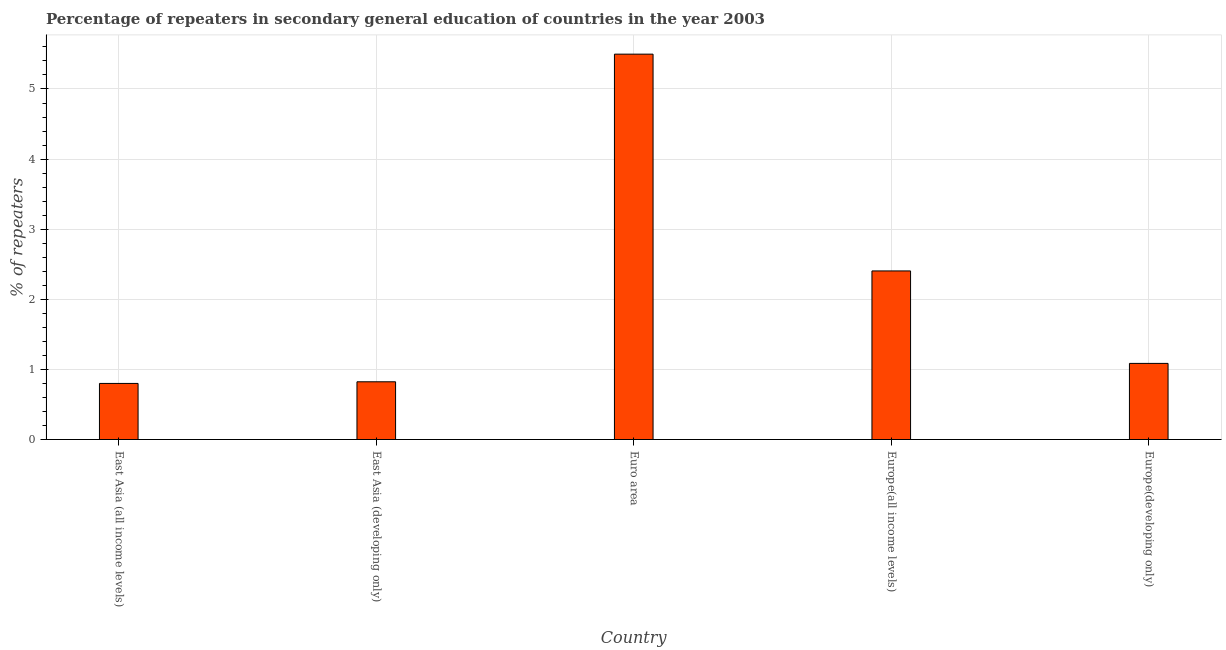Does the graph contain any zero values?
Give a very brief answer. No. What is the title of the graph?
Provide a succinct answer. Percentage of repeaters in secondary general education of countries in the year 2003. What is the label or title of the Y-axis?
Offer a terse response. % of repeaters. What is the percentage of repeaters in East Asia (developing only)?
Keep it short and to the point. 0.82. Across all countries, what is the maximum percentage of repeaters?
Offer a very short reply. 5.5. Across all countries, what is the minimum percentage of repeaters?
Provide a succinct answer. 0.8. In which country was the percentage of repeaters minimum?
Ensure brevity in your answer.  East Asia (all income levels). What is the sum of the percentage of repeaters?
Your answer should be compact. 10.61. What is the difference between the percentage of repeaters in East Asia (developing only) and Euro area?
Your answer should be compact. -4.67. What is the average percentage of repeaters per country?
Offer a terse response. 2.12. What is the median percentage of repeaters?
Offer a terse response. 1.09. In how many countries, is the percentage of repeaters greater than 2 %?
Offer a very short reply. 2. Is the difference between the percentage of repeaters in East Asia (developing only) and Euro area greater than the difference between any two countries?
Ensure brevity in your answer.  No. What is the difference between the highest and the second highest percentage of repeaters?
Make the answer very short. 3.09. What is the difference between the highest and the lowest percentage of repeaters?
Your response must be concise. 4.7. How many countries are there in the graph?
Provide a succinct answer. 5. What is the difference between two consecutive major ticks on the Y-axis?
Your answer should be compact. 1. What is the % of repeaters in East Asia (all income levels)?
Your response must be concise. 0.8. What is the % of repeaters in East Asia (developing only)?
Ensure brevity in your answer.  0.82. What is the % of repeaters of Euro area?
Give a very brief answer. 5.5. What is the % of repeaters in Europe(all income levels)?
Make the answer very short. 2.4. What is the % of repeaters of Europe(developing only)?
Offer a very short reply. 1.09. What is the difference between the % of repeaters in East Asia (all income levels) and East Asia (developing only)?
Keep it short and to the point. -0.02. What is the difference between the % of repeaters in East Asia (all income levels) and Euro area?
Give a very brief answer. -4.7. What is the difference between the % of repeaters in East Asia (all income levels) and Europe(all income levels)?
Your answer should be very brief. -1.6. What is the difference between the % of repeaters in East Asia (all income levels) and Europe(developing only)?
Offer a terse response. -0.29. What is the difference between the % of repeaters in East Asia (developing only) and Euro area?
Make the answer very short. -4.67. What is the difference between the % of repeaters in East Asia (developing only) and Europe(all income levels)?
Make the answer very short. -1.58. What is the difference between the % of repeaters in East Asia (developing only) and Europe(developing only)?
Give a very brief answer. -0.26. What is the difference between the % of repeaters in Euro area and Europe(all income levels)?
Provide a short and direct response. 3.09. What is the difference between the % of repeaters in Euro area and Europe(developing only)?
Give a very brief answer. 4.41. What is the difference between the % of repeaters in Europe(all income levels) and Europe(developing only)?
Offer a terse response. 1.32. What is the ratio of the % of repeaters in East Asia (all income levels) to that in Euro area?
Your response must be concise. 0.15. What is the ratio of the % of repeaters in East Asia (all income levels) to that in Europe(all income levels)?
Keep it short and to the point. 0.33. What is the ratio of the % of repeaters in East Asia (all income levels) to that in Europe(developing only)?
Provide a succinct answer. 0.74. What is the ratio of the % of repeaters in East Asia (developing only) to that in Europe(all income levels)?
Give a very brief answer. 0.34. What is the ratio of the % of repeaters in East Asia (developing only) to that in Europe(developing only)?
Provide a succinct answer. 0.76. What is the ratio of the % of repeaters in Euro area to that in Europe(all income levels)?
Give a very brief answer. 2.29. What is the ratio of the % of repeaters in Euro area to that in Europe(developing only)?
Keep it short and to the point. 5.06. What is the ratio of the % of repeaters in Europe(all income levels) to that in Europe(developing only)?
Make the answer very short. 2.21. 